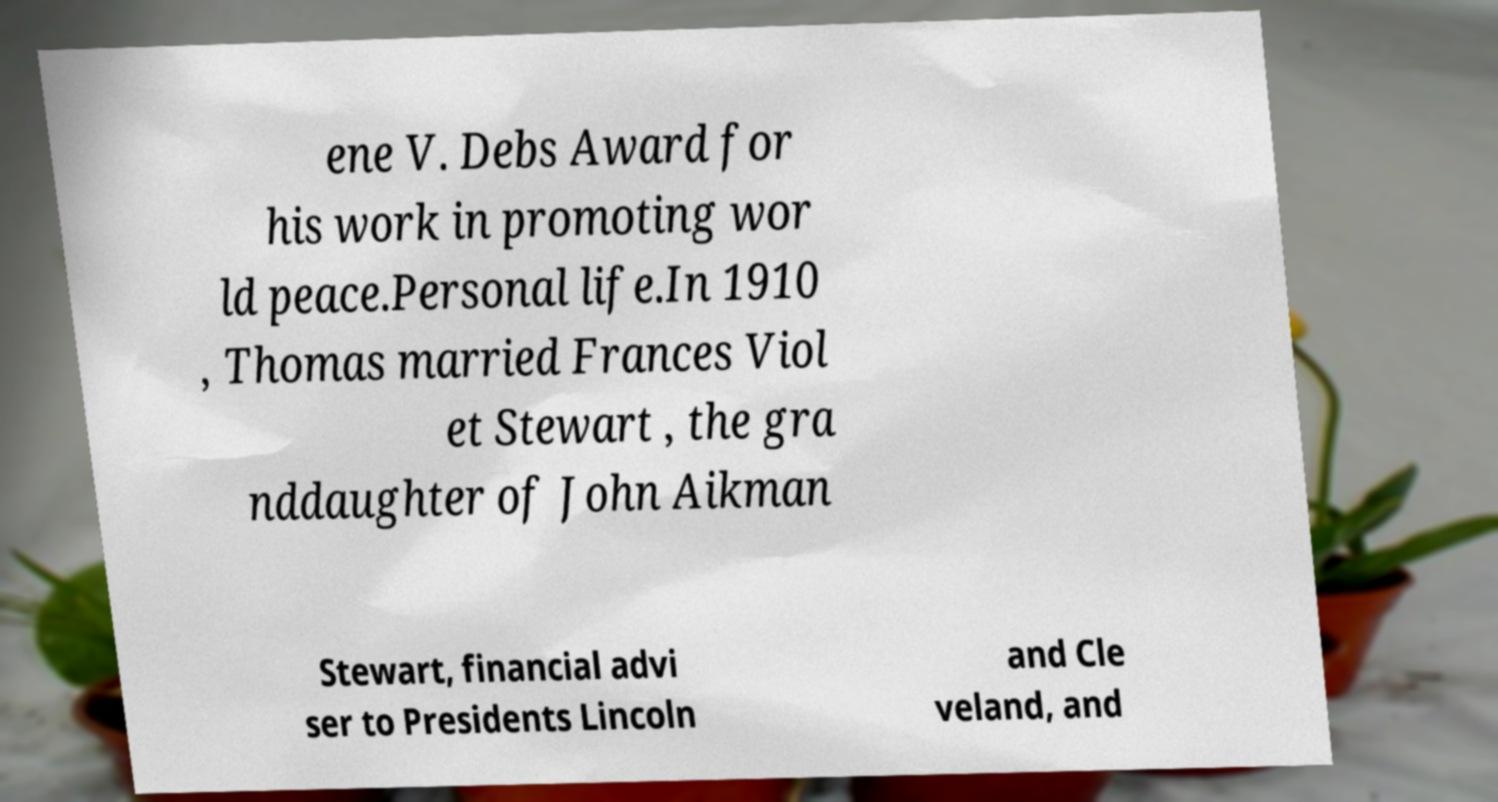Can you accurately transcribe the text from the provided image for me? ene V. Debs Award for his work in promoting wor ld peace.Personal life.In 1910 , Thomas married Frances Viol et Stewart , the gra nddaughter of John Aikman Stewart, financial advi ser to Presidents Lincoln and Cle veland, and 